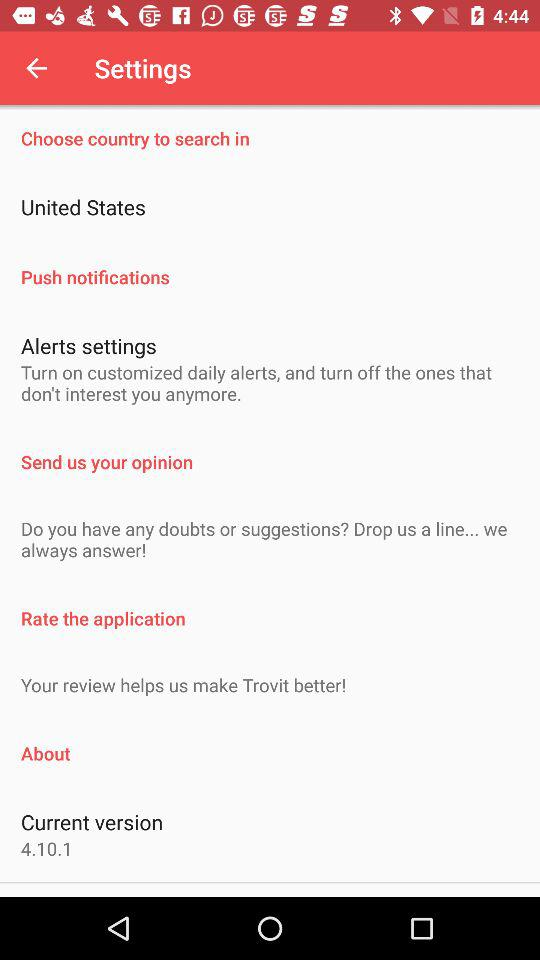What is the current version? The current version is 4.10.1. 